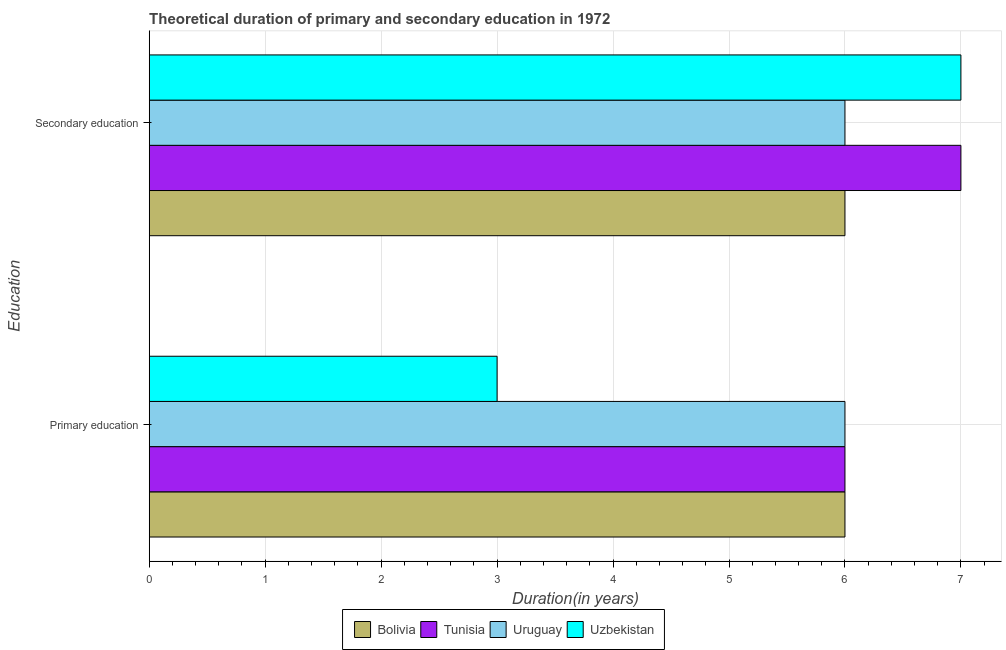How many bars are there on the 1st tick from the top?
Your answer should be compact. 4. How many bars are there on the 2nd tick from the bottom?
Your response must be concise. 4. What is the duration of secondary education in Uzbekistan?
Make the answer very short. 7. Across all countries, what is the maximum duration of secondary education?
Ensure brevity in your answer.  7. Across all countries, what is the minimum duration of primary education?
Make the answer very short. 3. In which country was the duration of primary education maximum?
Ensure brevity in your answer.  Bolivia. In which country was the duration of primary education minimum?
Your answer should be compact. Uzbekistan. What is the total duration of primary education in the graph?
Your answer should be compact. 21. What is the difference between the duration of secondary education in Bolivia and that in Tunisia?
Your answer should be very brief. -1. What is the average duration of primary education per country?
Make the answer very short. 5.25. What is the difference between the duration of primary education and duration of secondary education in Uruguay?
Keep it short and to the point. 0. What is the ratio of the duration of secondary education in Tunisia to that in Bolivia?
Your response must be concise. 1.17. What does the 2nd bar from the top in Secondary education represents?
Give a very brief answer. Uruguay. What does the 4th bar from the bottom in Secondary education represents?
Your response must be concise. Uzbekistan. Are all the bars in the graph horizontal?
Your answer should be very brief. Yes. What is the difference between two consecutive major ticks on the X-axis?
Offer a terse response. 1. Are the values on the major ticks of X-axis written in scientific E-notation?
Make the answer very short. No. Does the graph contain any zero values?
Offer a very short reply. No. Does the graph contain grids?
Offer a terse response. Yes. Where does the legend appear in the graph?
Your answer should be compact. Bottom center. How many legend labels are there?
Give a very brief answer. 4. What is the title of the graph?
Your response must be concise. Theoretical duration of primary and secondary education in 1972. What is the label or title of the X-axis?
Your response must be concise. Duration(in years). What is the label or title of the Y-axis?
Keep it short and to the point. Education. What is the Duration(in years) in Uruguay in Primary education?
Offer a very short reply. 6. What is the Duration(in years) in Uzbekistan in Primary education?
Give a very brief answer. 3. What is the Duration(in years) in Tunisia in Secondary education?
Your response must be concise. 7. Across all Education, what is the maximum Duration(in years) in Uruguay?
Make the answer very short. 6. Across all Education, what is the maximum Duration(in years) of Uzbekistan?
Provide a succinct answer. 7. Across all Education, what is the minimum Duration(in years) in Tunisia?
Provide a succinct answer. 6. Across all Education, what is the minimum Duration(in years) of Uruguay?
Ensure brevity in your answer.  6. Across all Education, what is the minimum Duration(in years) of Uzbekistan?
Keep it short and to the point. 3. What is the total Duration(in years) in Tunisia in the graph?
Keep it short and to the point. 13. What is the difference between the Duration(in years) in Tunisia in Primary education and that in Secondary education?
Provide a succinct answer. -1. What is the difference between the Duration(in years) of Uruguay in Primary education and that in Secondary education?
Your answer should be compact. 0. What is the difference between the Duration(in years) in Bolivia in Primary education and the Duration(in years) in Tunisia in Secondary education?
Provide a succinct answer. -1. What is the difference between the Duration(in years) of Tunisia in Primary education and the Duration(in years) of Uruguay in Secondary education?
Your response must be concise. 0. What is the average Duration(in years) in Bolivia per Education?
Offer a terse response. 6. What is the average Duration(in years) in Uzbekistan per Education?
Ensure brevity in your answer.  5. What is the difference between the Duration(in years) in Tunisia and Duration(in years) in Uzbekistan in Primary education?
Your answer should be compact. 3. What is the difference between the Duration(in years) of Bolivia and Duration(in years) of Tunisia in Secondary education?
Provide a short and direct response. -1. What is the difference between the Duration(in years) in Bolivia and Duration(in years) in Uruguay in Secondary education?
Offer a very short reply. 0. What is the difference between the Duration(in years) of Bolivia and Duration(in years) of Uzbekistan in Secondary education?
Offer a terse response. -1. What is the difference between the Duration(in years) of Tunisia and Duration(in years) of Uzbekistan in Secondary education?
Give a very brief answer. 0. What is the difference between the Duration(in years) of Uruguay and Duration(in years) of Uzbekistan in Secondary education?
Your response must be concise. -1. What is the ratio of the Duration(in years) of Uruguay in Primary education to that in Secondary education?
Provide a succinct answer. 1. What is the ratio of the Duration(in years) of Uzbekistan in Primary education to that in Secondary education?
Provide a short and direct response. 0.43. What is the difference between the highest and the second highest Duration(in years) in Bolivia?
Offer a very short reply. 0. What is the difference between the highest and the lowest Duration(in years) of Bolivia?
Offer a terse response. 0. What is the difference between the highest and the lowest Duration(in years) of Uruguay?
Provide a succinct answer. 0. What is the difference between the highest and the lowest Duration(in years) of Uzbekistan?
Give a very brief answer. 4. 